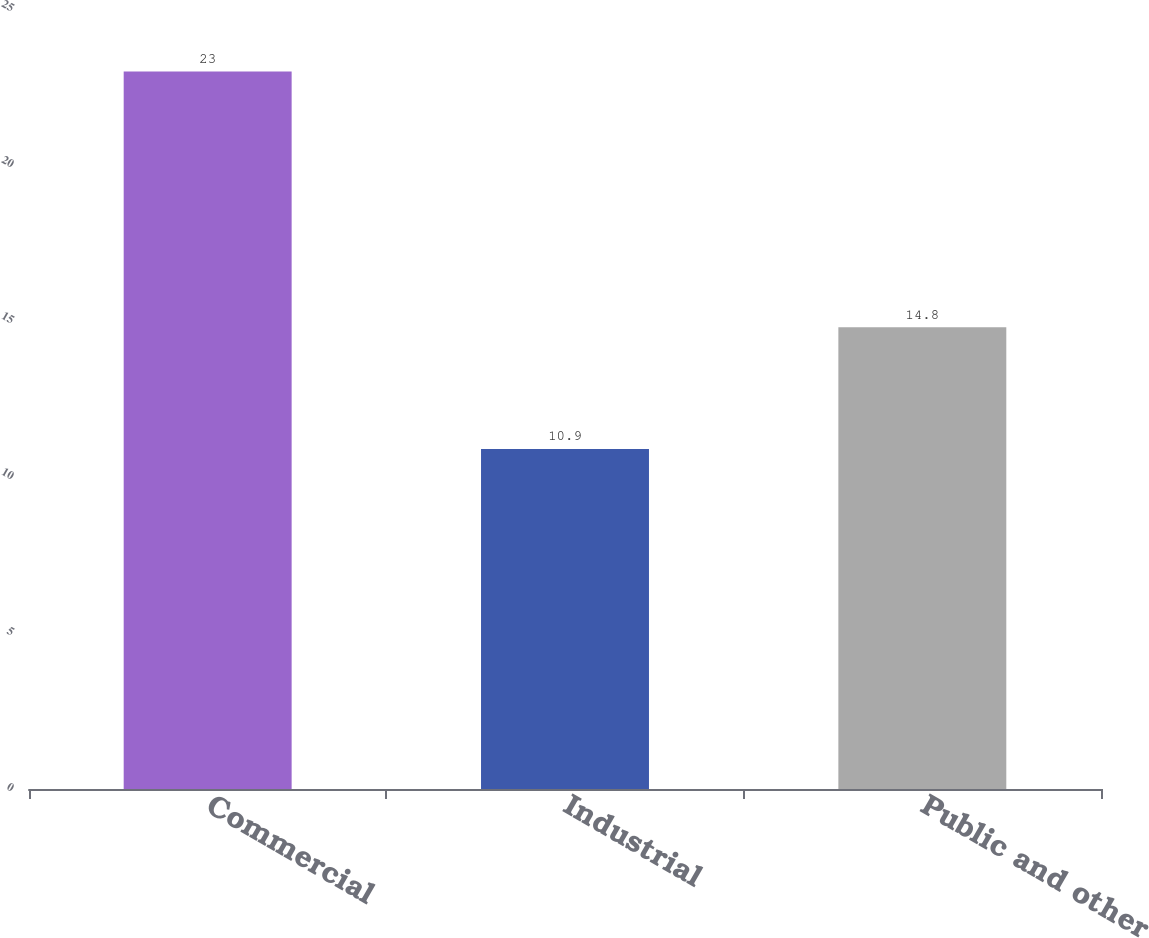Convert chart. <chart><loc_0><loc_0><loc_500><loc_500><bar_chart><fcel>Commercial<fcel>Industrial<fcel>Public and other<nl><fcel>23<fcel>10.9<fcel>14.8<nl></chart> 